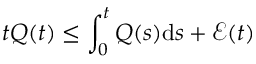Convert formula to latex. <formula><loc_0><loc_0><loc_500><loc_500>t Q ( t ) \leq \int _ { 0 } ^ { t } Q ( s ) d s + \mathcal { E } ( t )</formula> 